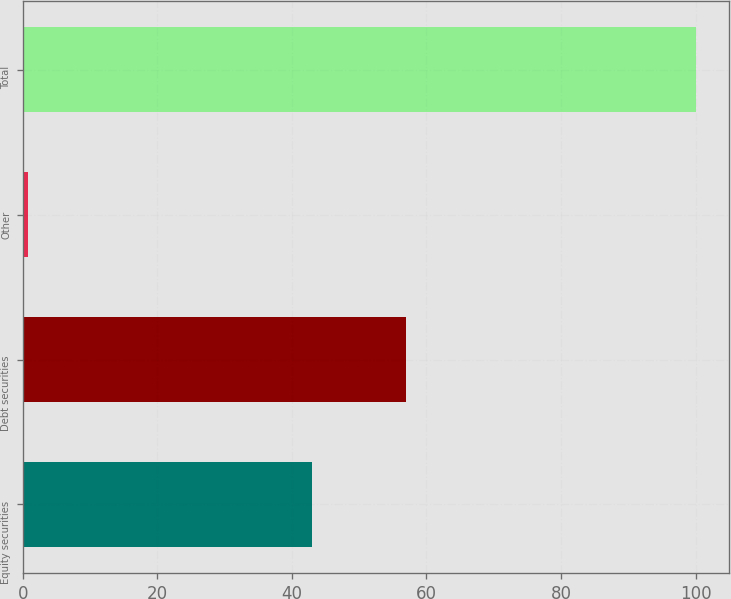<chart> <loc_0><loc_0><loc_500><loc_500><bar_chart><fcel>Equity securities<fcel>Debt securities<fcel>Other<fcel>Total<nl><fcel>43<fcel>57<fcel>0.83<fcel>100<nl></chart> 